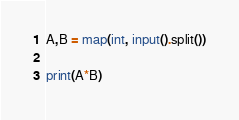<code> <loc_0><loc_0><loc_500><loc_500><_Python_>A,B = map(int, input().split())

print(A*B)</code> 